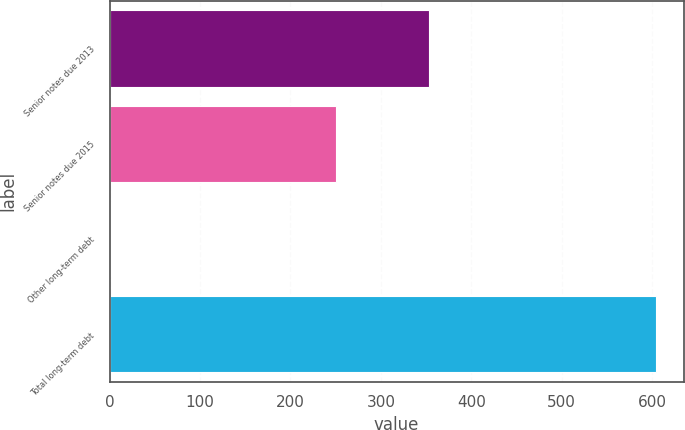Convert chart. <chart><loc_0><loc_0><loc_500><loc_500><bar_chart><fcel>Senior notes due 2013<fcel>Senior notes due 2015<fcel>Other long-term debt<fcel>Total long-term debt<nl><fcel>353<fcel>250<fcel>1.5<fcel>604.5<nl></chart> 